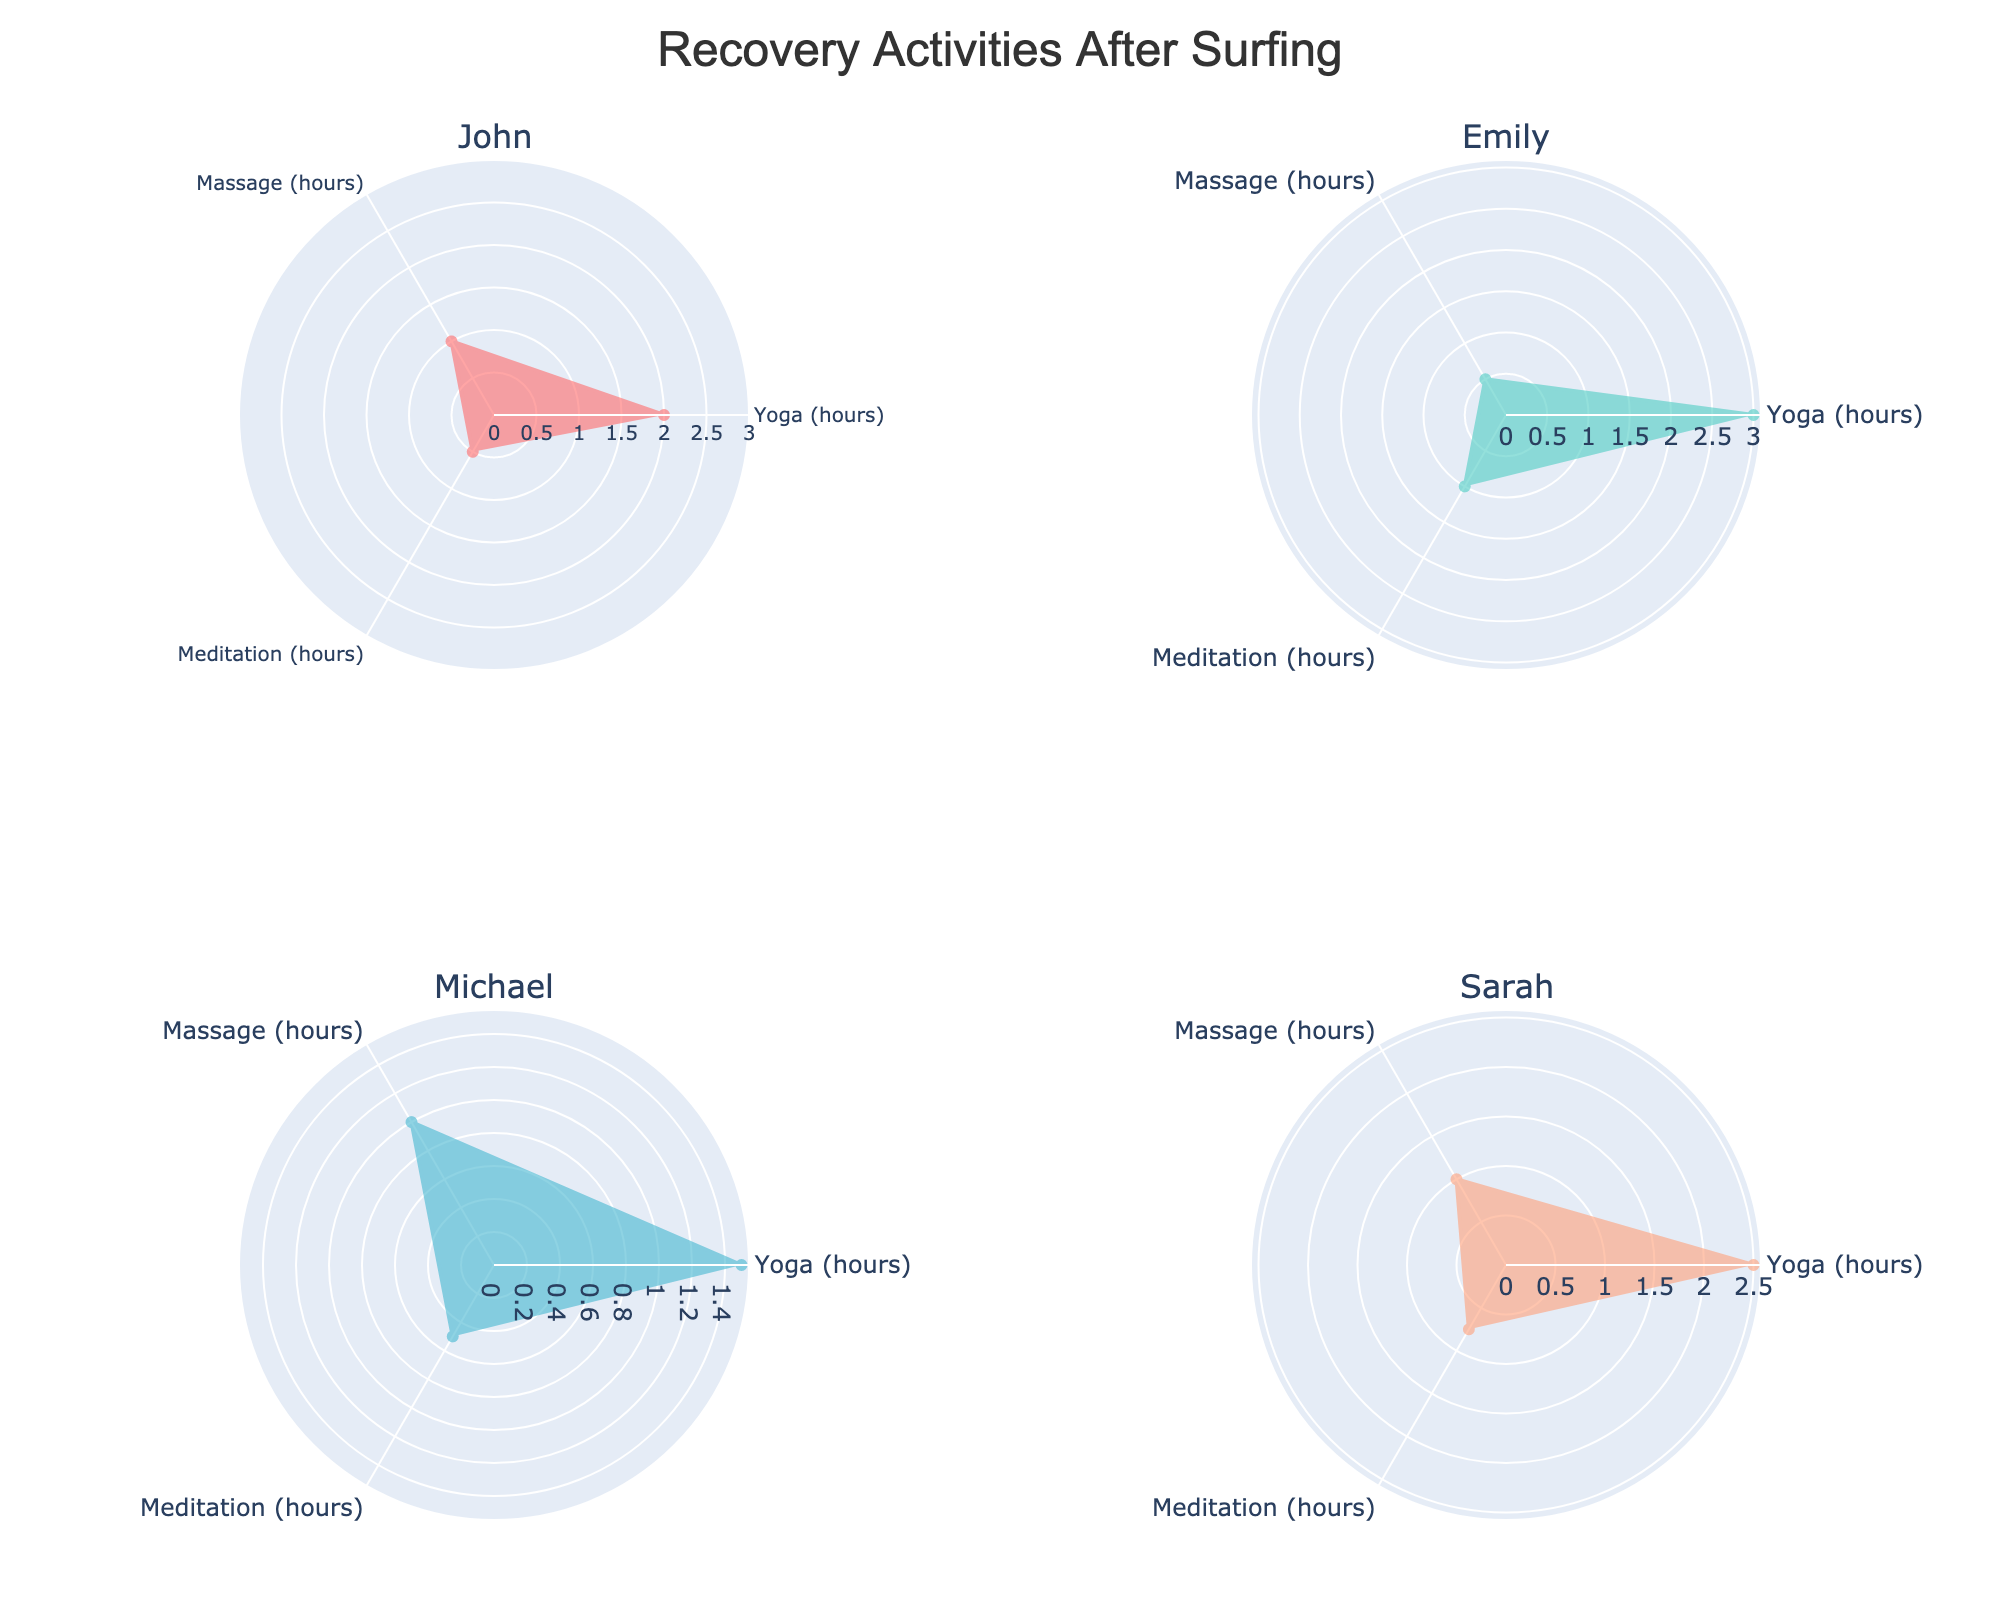What is the maximum time spent on Yoga by any individual? By looking at the radar charts, we see the maximum value for Yoga is 3 hours, which is achieved by Emily.
Answer: 3 hours Which individual spends the least amount of time on Massage? Referring to the radar charts, we notice that Emily spends the least time on Massage, which is 0.5 hours.
Answer: Emily How much total time does John spend on all recovery activities? According to the radar chart, John spends 2 hours on Yoga, 1 hour on Massage, and 0.5 hours on Meditation. Adding these, 2 + 1 + 0.5 = 3.5 hours.
Answer: 3.5 hours Between Sarah and Michael, who spends more time on Meditation? Sarah’s Meditation time is 0.75 hours, whereas Michael's Meditation time is 0.5 hours. Therefore, Sarah spends more time.
Answer: Sarah What is the average time that the individuals spend on Massage? The times spent on Massage are: John 1 hour, Emily 0.5 hours, Michael 1 hour, and Sarah 1 hour. The average is (1 + 0.5 + 1 + 1) / 4 = 0.875 hours.
Answer: 0.875 hours Who spends the most balanced time across all activities (Yoga, Massage, Meditation)? By examining the charts, Michael spends 1.5 hours on Yoga, 1 hour on Massage, and 0.5 hours on Meditation. His chart shows the most balanced distribution as his times are relatively even across all activities.
Answer: Michael By how many hours does the total time Emily spends on Yoga exceed her Massage time? Emily spends 3 hours on Yoga and 0.5 hours on Massage. The difference is 3 - 0.5 = 2.5 hours.
Answer: 2.5 hours Which activity shows the greatest variability in time spent among all individuals? Observing each radar chart, Yoga times range from 1.5 to 3 hours, Massage ranges from 0.5 to 1 hour, and Meditation ranges from 0.5 to 1 hour. Yoga shows the greatest range and thus variability.
Answer: Yoga 